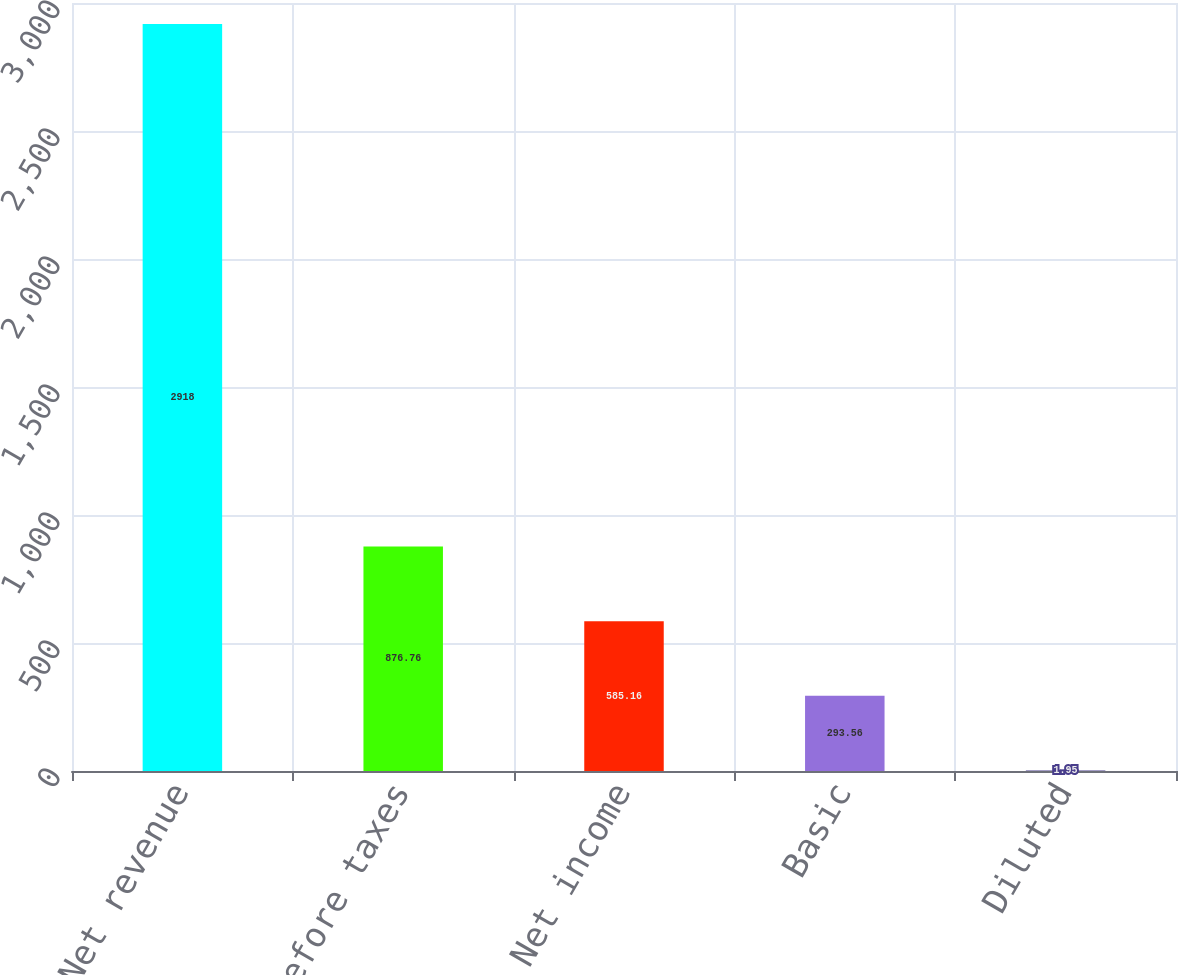<chart> <loc_0><loc_0><loc_500><loc_500><bar_chart><fcel>Net revenue<fcel>Income before taxes<fcel>Net income<fcel>Basic<fcel>Diluted<nl><fcel>2918<fcel>876.76<fcel>585.16<fcel>293.56<fcel>1.95<nl></chart> 